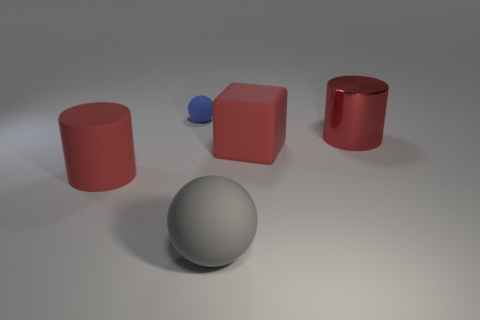What number of other things are there of the same material as the tiny sphere
Your answer should be very brief. 3. What number of objects are either large red rubber things on the right side of the small blue rubber sphere or big red objects that are left of the big red matte block?
Offer a very short reply. 2. Is the shape of the red thing that is left of the tiny object the same as the metal thing that is behind the gray matte sphere?
Your response must be concise. Yes. What shape is the other metallic thing that is the same size as the gray object?
Your answer should be compact. Cylinder. How many shiny objects are either tiny brown objects or red blocks?
Offer a very short reply. 0. Is the big red thing that is on the left side of the small blue ball made of the same material as the ball behind the red shiny cylinder?
Provide a succinct answer. Yes. What color is the block that is made of the same material as the gray ball?
Your answer should be very brief. Red. Are there more big gray objects on the right side of the large shiny cylinder than gray balls on the right side of the red block?
Ensure brevity in your answer.  No. Is there a small brown block?
Keep it short and to the point. No. There is a cube that is the same color as the rubber cylinder; what is its material?
Your answer should be very brief. Rubber. 